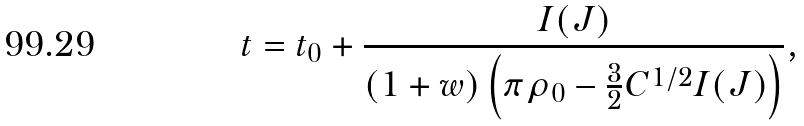Convert formula to latex. <formula><loc_0><loc_0><loc_500><loc_500>t = t _ { 0 } + \frac { I ( J ) } { \left ( 1 + w \right ) \left ( \pi \rho _ { 0 } - \frac { 3 } { 2 } C ^ { 1 / 2 } I ( J ) \right ) } ,</formula> 